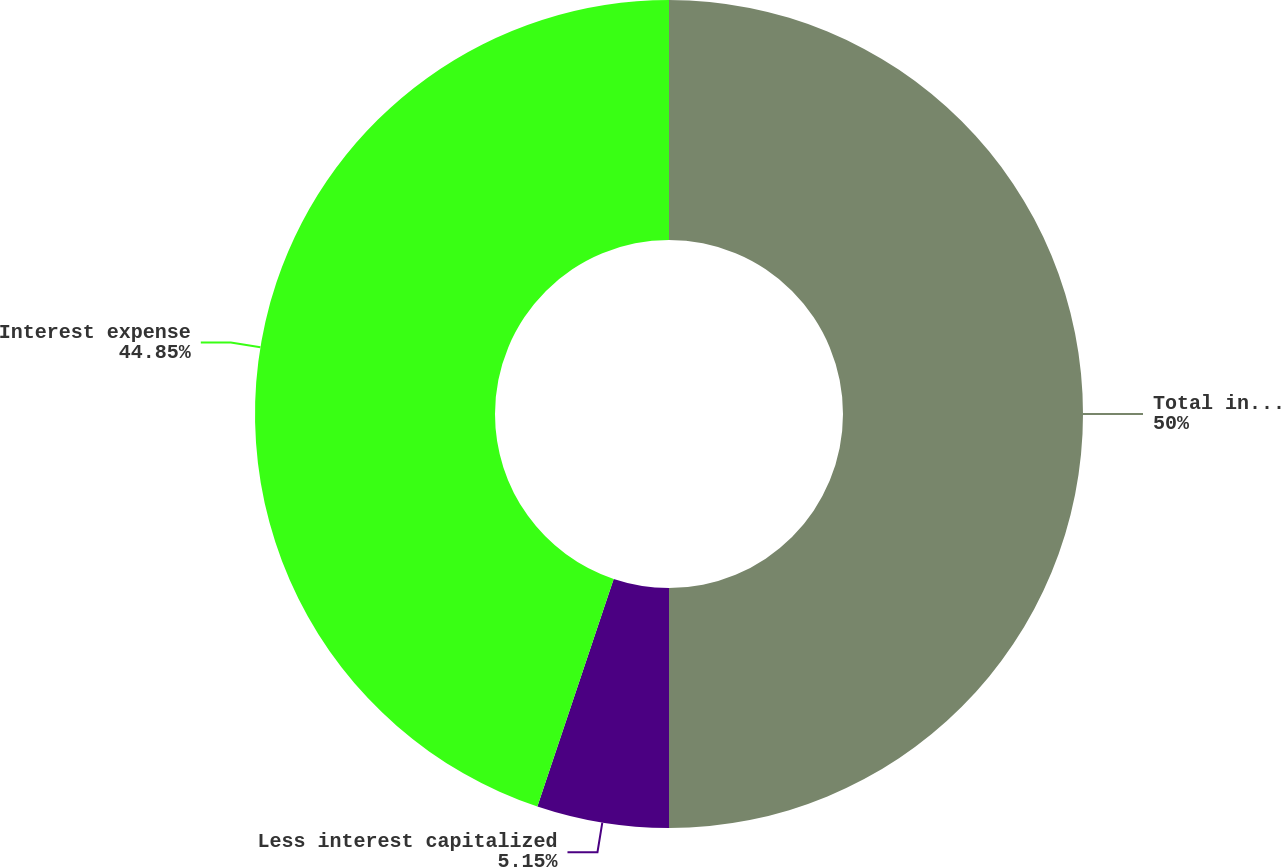<chart> <loc_0><loc_0><loc_500><loc_500><pie_chart><fcel>Total interest charges<fcel>Less interest capitalized<fcel>Interest expense<nl><fcel>50.0%<fcel>5.15%<fcel>44.85%<nl></chart> 